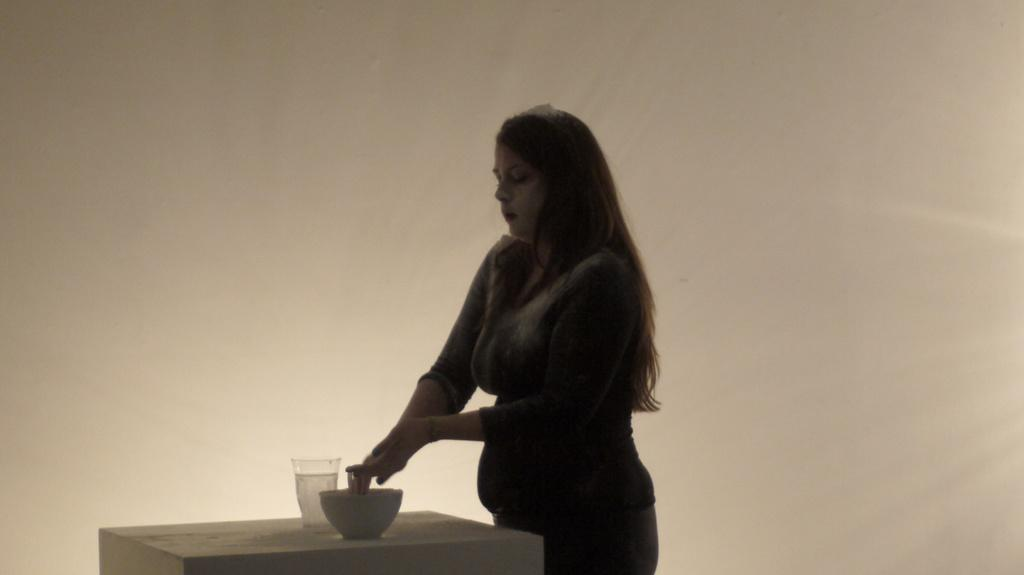Who is present in the image? There is a woman in the image. What is the woman doing in the image? The woman is standing. What objects can be seen on the table in the image? There is a bowl and a glass on the table in the image. What is the color of the background in the image? The background of the image is cream-colored. What type of business is the woman conducting in the image? There is no indication of any business activity in the image; the woman is simply standing. Can you tell me how many times the woman is rubbing her hands in the image? There is no rubbing of hands visible in the image. 